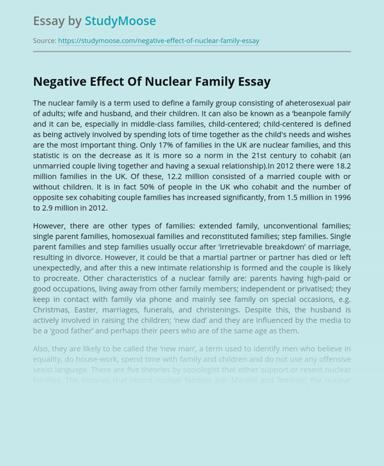What is the main topic discussed in the essay mentioned in the image? The essay discusses the perceived negative effects of nuclear families and explores various alternative family structures. It critically examines how societal and cultural shifts have influenced family dynamics, noting the transition towards more varied and non-traditional arrangements. 